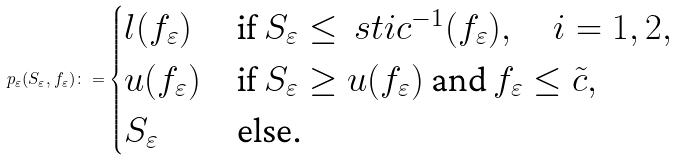Convert formula to latex. <formula><loc_0><loc_0><loc_500><loc_500>p _ { \varepsilon } ( S _ { \varepsilon } , f _ { \varepsilon } ) \colon = \begin{cases} l ( f _ { \varepsilon } ) & \text {if } S _ { \varepsilon } \leq \ s t i { c } ^ { - 1 } ( f _ { \varepsilon } ) , \quad i = 1 , 2 , \\ u ( f _ { \varepsilon } ) & \text {if } S _ { \varepsilon } \geq u ( f _ { \varepsilon } ) \text { and } f _ { \varepsilon } \leq \tilde { c } , \\ S _ { \varepsilon } & \text {else.} \end{cases}</formula> 